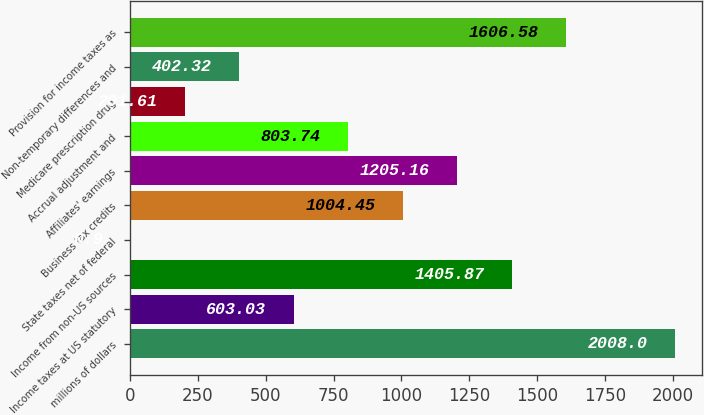Convert chart. <chart><loc_0><loc_0><loc_500><loc_500><bar_chart><fcel>millions of dollars<fcel>Income taxes at US statutory<fcel>Income from non-US sources<fcel>State taxes net of federal<fcel>Business tax credits<fcel>Affiliates' earnings<fcel>Accrual adjustment and<fcel>Medicare prescription drug<fcel>Non-temporary differences and<fcel>Provision for income taxes as<nl><fcel>2008<fcel>603.03<fcel>1405.87<fcel>0.9<fcel>1004.45<fcel>1205.16<fcel>803.74<fcel>201.61<fcel>402.32<fcel>1606.58<nl></chart> 